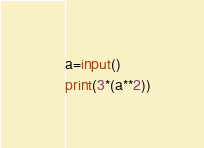<code> <loc_0><loc_0><loc_500><loc_500><_Python_>a=input()
print(3*(a**2))</code> 